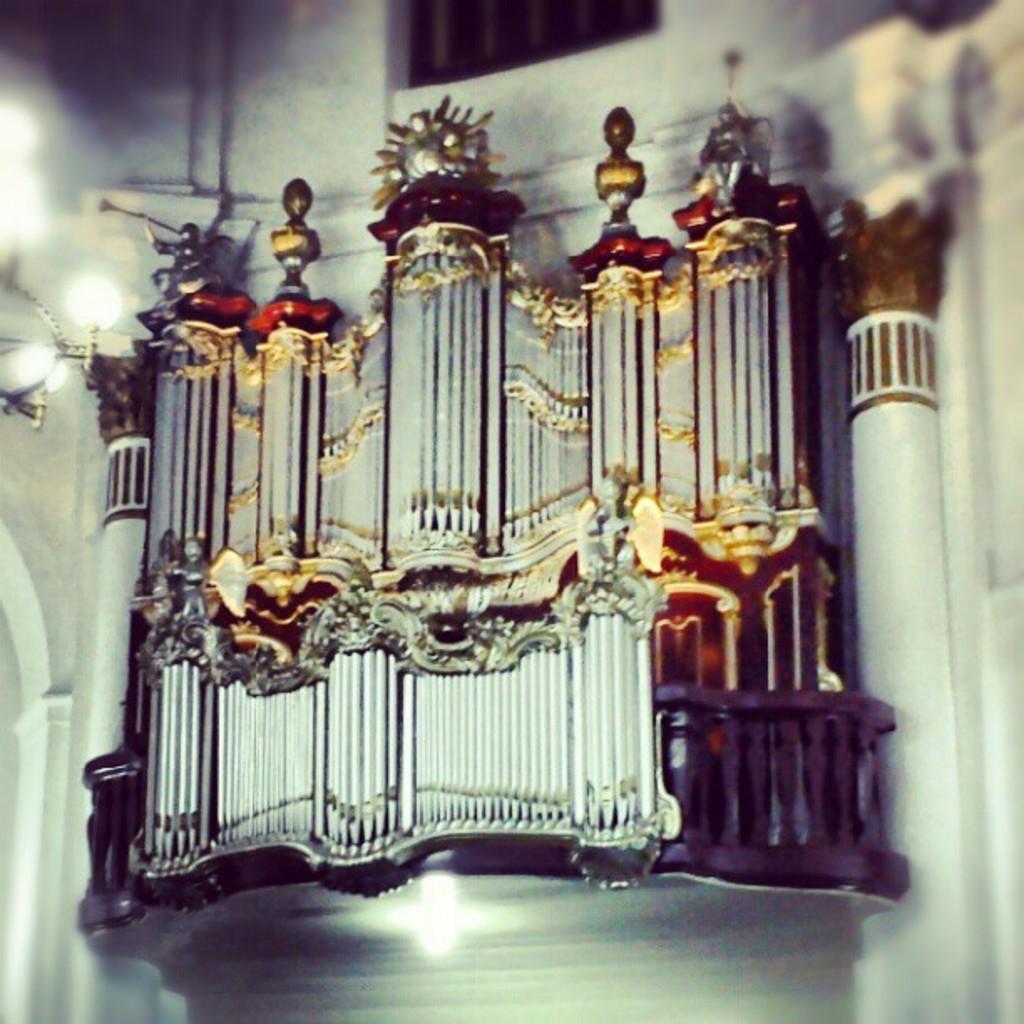In one or two sentences, can you explain what this image depicts? In this image we can see a structure look like a sculpture to the wall and there are lights in front of the sculpture. 